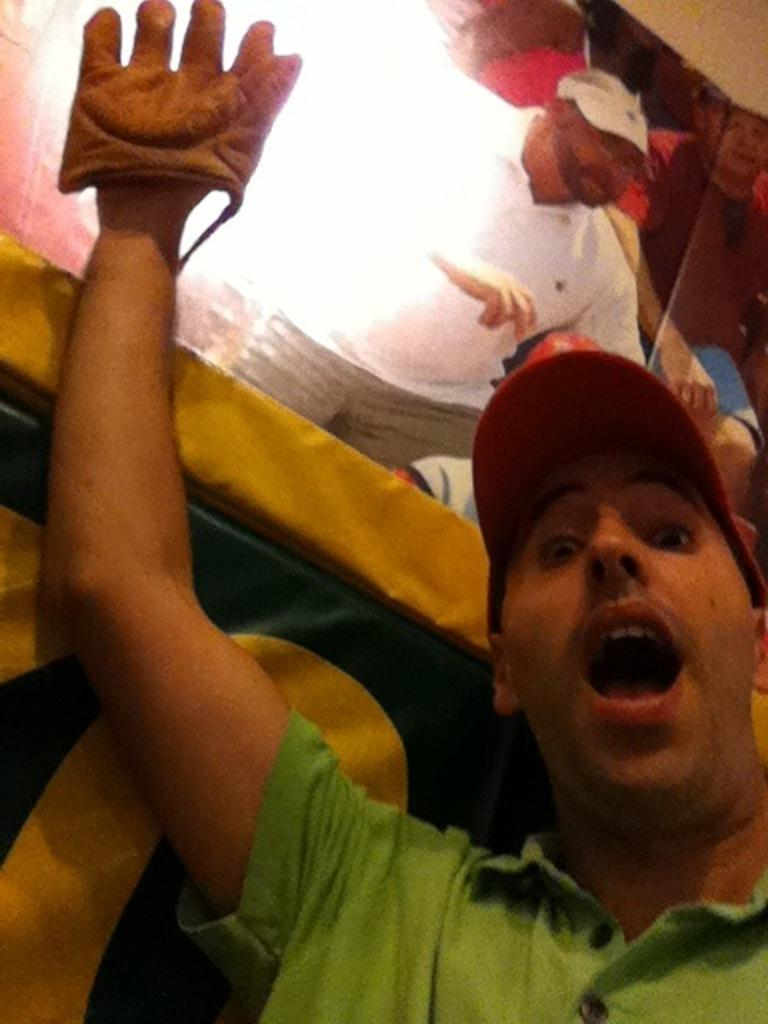Who is the main subject in the image? There is a person in the center of the image. What is the person wearing on their head? The person is wearing a cap. What is the person wearing on their hand? The person is wearing a glove. What can be seen in the background of the image? There is a wall and a cloth in the background of the image. Can you tell me how many times the person sneezes in the image? There is no indication of the person sneezing in the image. What type of volleyball game is being played in the background of the image? There is no volleyball game present in the image; it only features a person, a cap, a glove, a wall, and a cloth. 